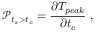<formula> <loc_0><loc_0><loc_500><loc_500>\ m a t h s c r { P } _ { t _ { s } > t _ { c } } = \frac { \partial T _ { p e a k } } { \partial t _ { c } } ,</formula> 